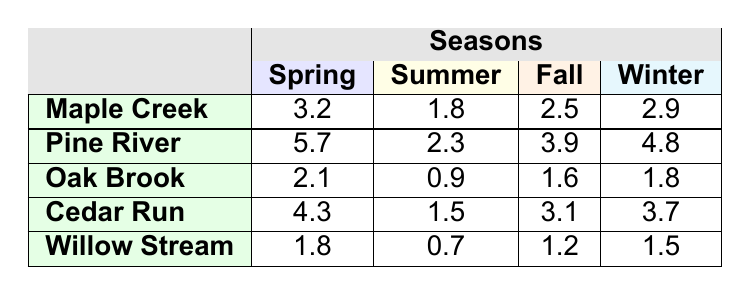What is the flow rate of Willow Stream in Summer? The table shows that the flow rate of Willow Stream during the Summer season is 0.7.
Answer: 0.7 Which stream has the highest flow rate in Spring? By looking at the Spring column, Pine River has the highest flow rate of 5.7 among all streams.
Answer: Pine River What is the average flow rate of Maple Creek throughout the seasons? To calculate the average flow rate of Maple Creek, sum the flow rates: 3.2 + 1.8 + 2.5 + 2.9 = 10.4. There are 4 seasons, so the average is 10.4 / 4 = 2.6.
Answer: 2.6 Which stream has the lowest flow rate in Fall? Checking the Fall column, Willow Stream has the lowest flow rate of 1.2.
Answer: Willow Stream Is the flow rate of Cedar Run in Winter greater than 3? The table shows Cedar Run's flow rate in Winter is 3.7, which is greater than 3. So the answer is yes.
Answer: Yes What is the total flow rate of Oak Brook across all seasons? To find the total flow rate of Oak Brook, add the flow rates for all seasons: 2.1 + 0.9 + 1.6 + 1.8 = 6.4.
Answer: 6.4 How does the Spring flow rate of Pine River compare to Willow Stream? In Spring, Pine River's flow rate is 5.7 while Willow Stream's is 1.8. The difference is 5.7 - 1.8 = 3.9, indicating Pine River has a higher flow rate by 3.9.
Answer: Pine River is higher by 3.9 What season does Oak Brook have the highest flow rate? Looking through Oak Brook's flow rates, the highest value is in Spring at 2.1.
Answer: Spring Are the flow rates in Winter higher than in Fall for any stream? Checking the table, for Pine River (4.8 in Winter vs 3.9 in Fall) and Cedar Run (3.7 in Winter vs 3.1 in Fall), both have higher flow rates in Winter. So, the answer is yes.
Answer: Yes What is the difference in flow rate between the highest and lowest streams in Summer? The highest flow rate in Summer is Pine River at 2.3, and the lowest is Willow Stream at 0.7. The difference is 2.3 - 0.7 = 1.6.
Answer: 1.6 